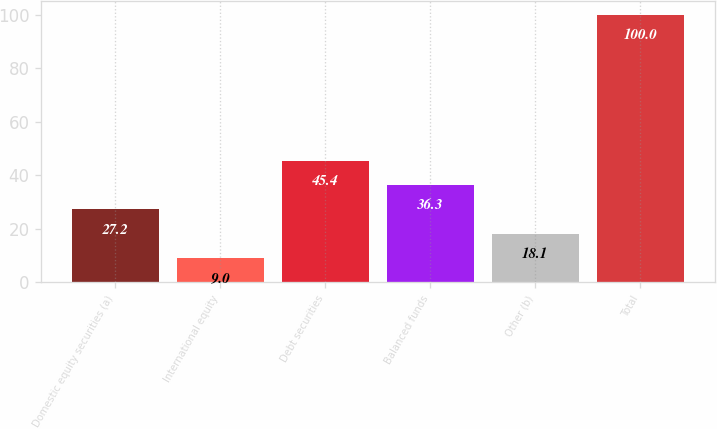Convert chart to OTSL. <chart><loc_0><loc_0><loc_500><loc_500><bar_chart><fcel>Domestic equity securities (a)<fcel>International equity<fcel>Debt securities<fcel>Balanced funds<fcel>Other (b)<fcel>Total<nl><fcel>27.2<fcel>9<fcel>45.4<fcel>36.3<fcel>18.1<fcel>100<nl></chart> 